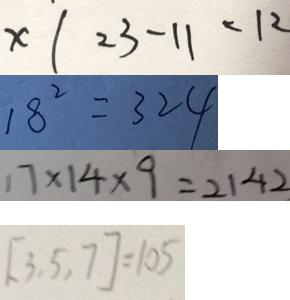<formula> <loc_0><loc_0><loc_500><loc_500>x \vert 2 3 - 1 1 < 1 2 
 1 8 ^ { 2 } = 3 2 4 
 1 7 \times 1 4 \times 9 = 2 1 4 2 
 [ 3 , 5 , 7 ] = 1 0 5</formula> 